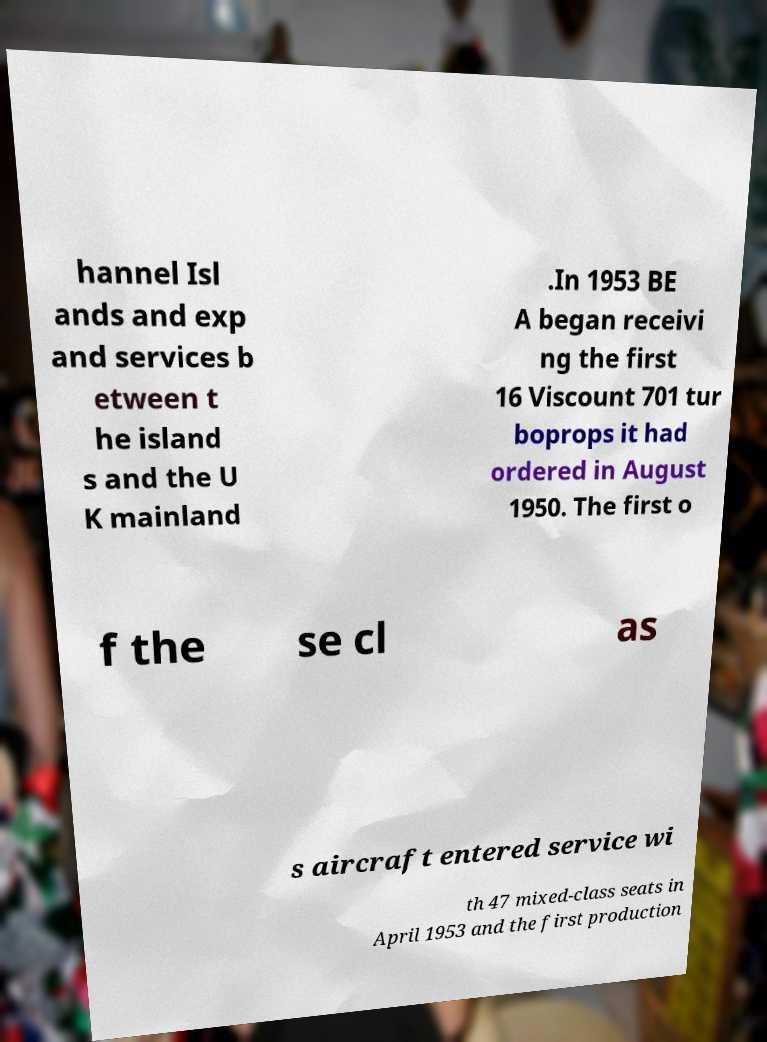Please identify and transcribe the text found in this image. hannel Isl ands and exp and services b etween t he island s and the U K mainland .In 1953 BE A began receivi ng the first 16 Viscount 701 tur boprops it had ordered in August 1950. The first o f the se cl as s aircraft entered service wi th 47 mixed-class seats in April 1953 and the first production 